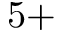<formula> <loc_0><loc_0><loc_500><loc_500>5 +</formula> 